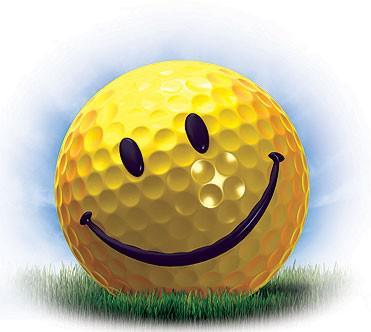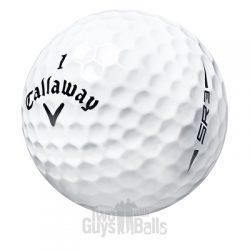The first image is the image on the left, the second image is the image on the right. Considering the images on both sides, is "In one of the images there is a golf ball with a face printed on it." valid? Answer yes or no. Yes. The first image is the image on the left, the second image is the image on the right. For the images displayed, is the sentence "Exactly one standard white golf ball is shown in each image, with its brand name stamped in black and a number either above or below it." factually correct? Answer yes or no. No. 